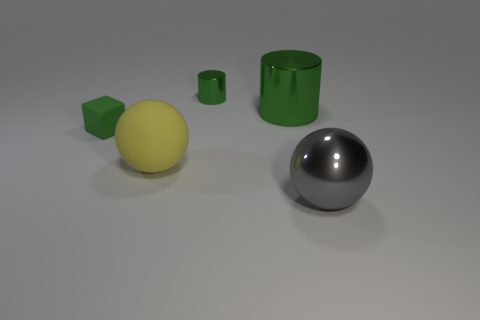What do these objects seem to be, and is there any indication of their use? The objects in the image appear to be geometric shapes that are often used in visual compositions to illustrate concepts such as lighting, texture, and perspective. They are not functional objects but rather seem to be models typically used for three-dimensional rendering tests or educational purposes to demonstrate the properties of different shapes and materials. 